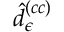<formula> <loc_0><loc_0><loc_500><loc_500>\hat { d } _ { \epsilon } ^ { \left ( c c \right ) }</formula> 